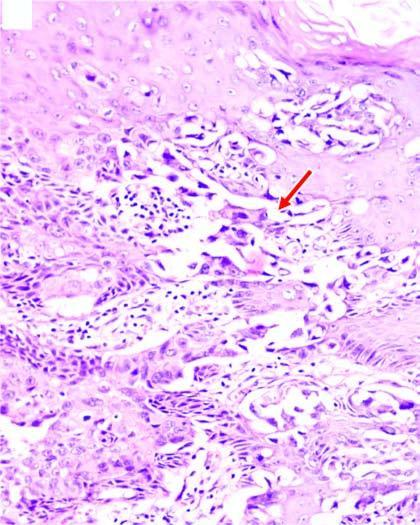what are there in the epidermal layers containing large tumour cells?
Answer the question using a single word or phrase. Clefts in the epidermal layers 